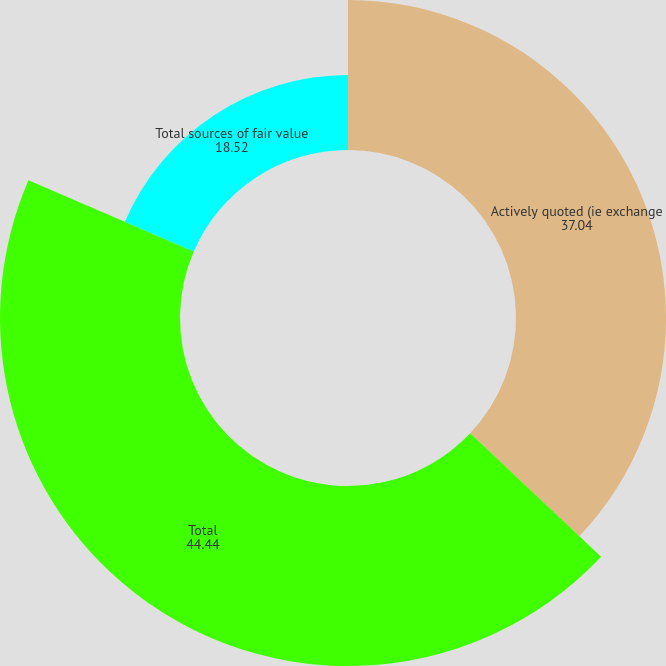Convert chart. <chart><loc_0><loc_0><loc_500><loc_500><pie_chart><fcel>Actively quoted (ie exchange<fcel>Total<fcel>Total sources of fair value<nl><fcel>37.04%<fcel>44.44%<fcel>18.52%<nl></chart> 